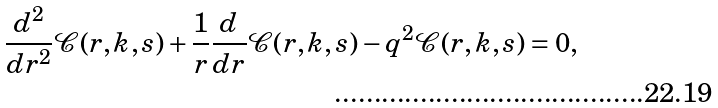Convert formula to latex. <formula><loc_0><loc_0><loc_500><loc_500>\frac { d ^ { 2 } } { d r ^ { 2 } } \mathcal { C } ( r , k , s ) + \frac { 1 } { r } \frac { d } { d r } \mathcal { C } ( r , k , s ) - q ^ { 2 } \mathcal { C } ( r , k , s ) = 0 ,</formula> 